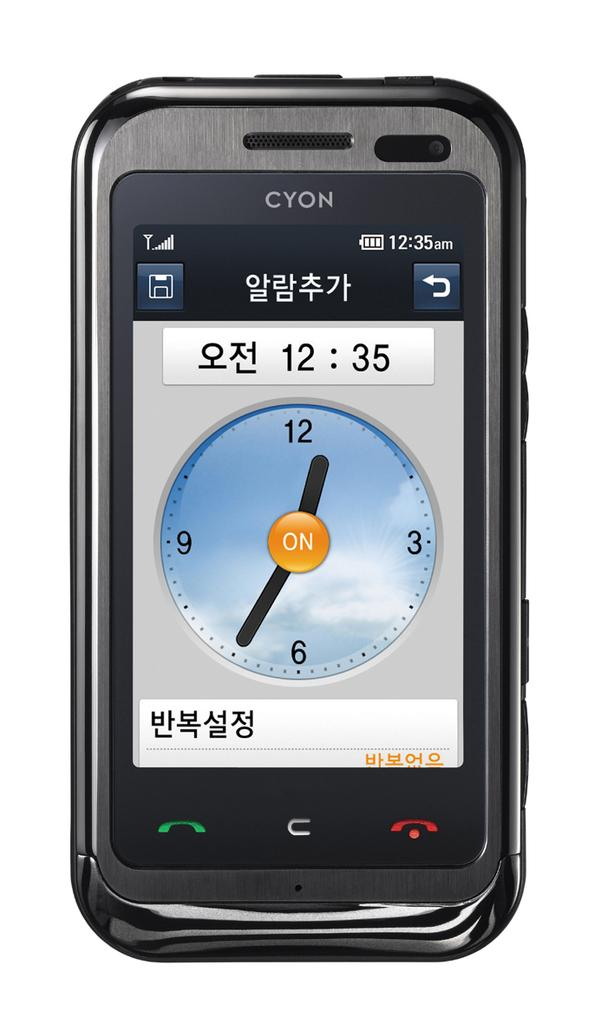Provide a one-sentence caption for the provided image. A clock app on a CYON phone indicated the time is 12:35. 